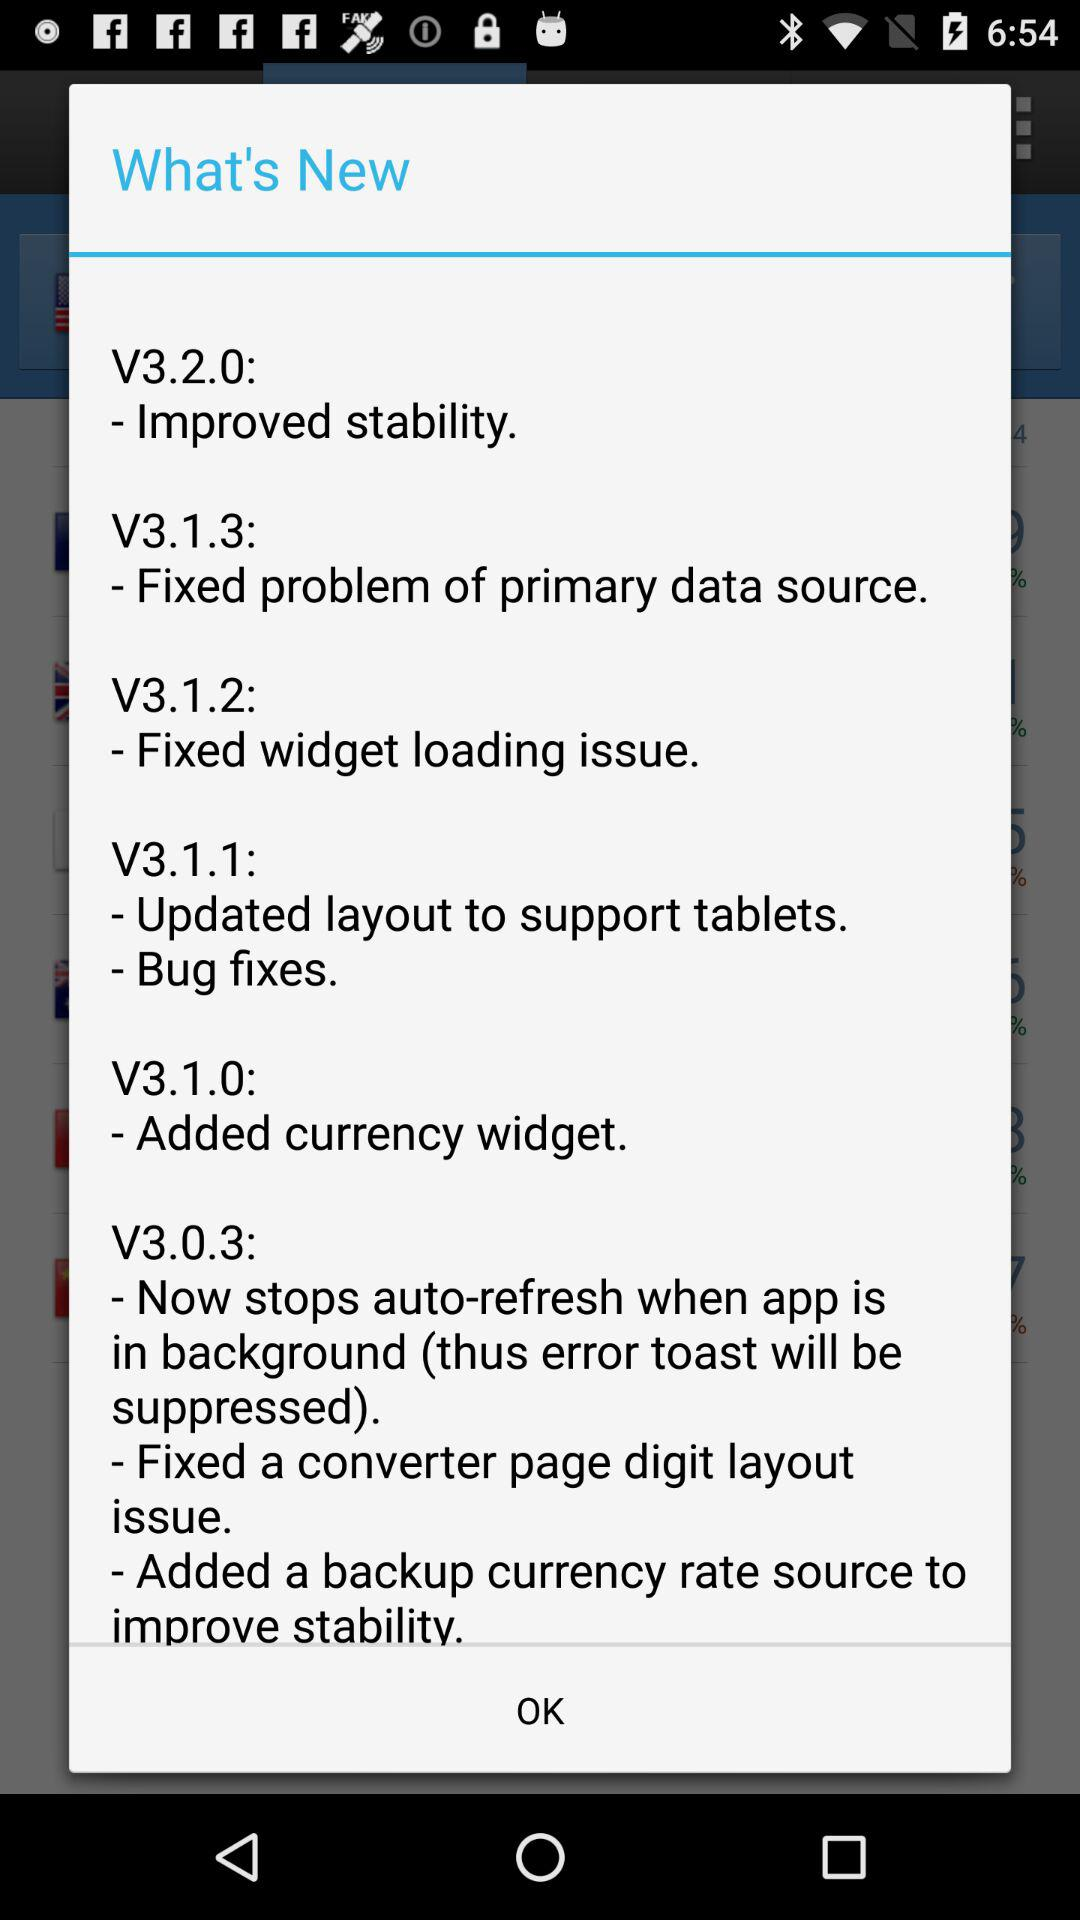What is the new feature in V3.2.0? The new feature is "Improved stability". 